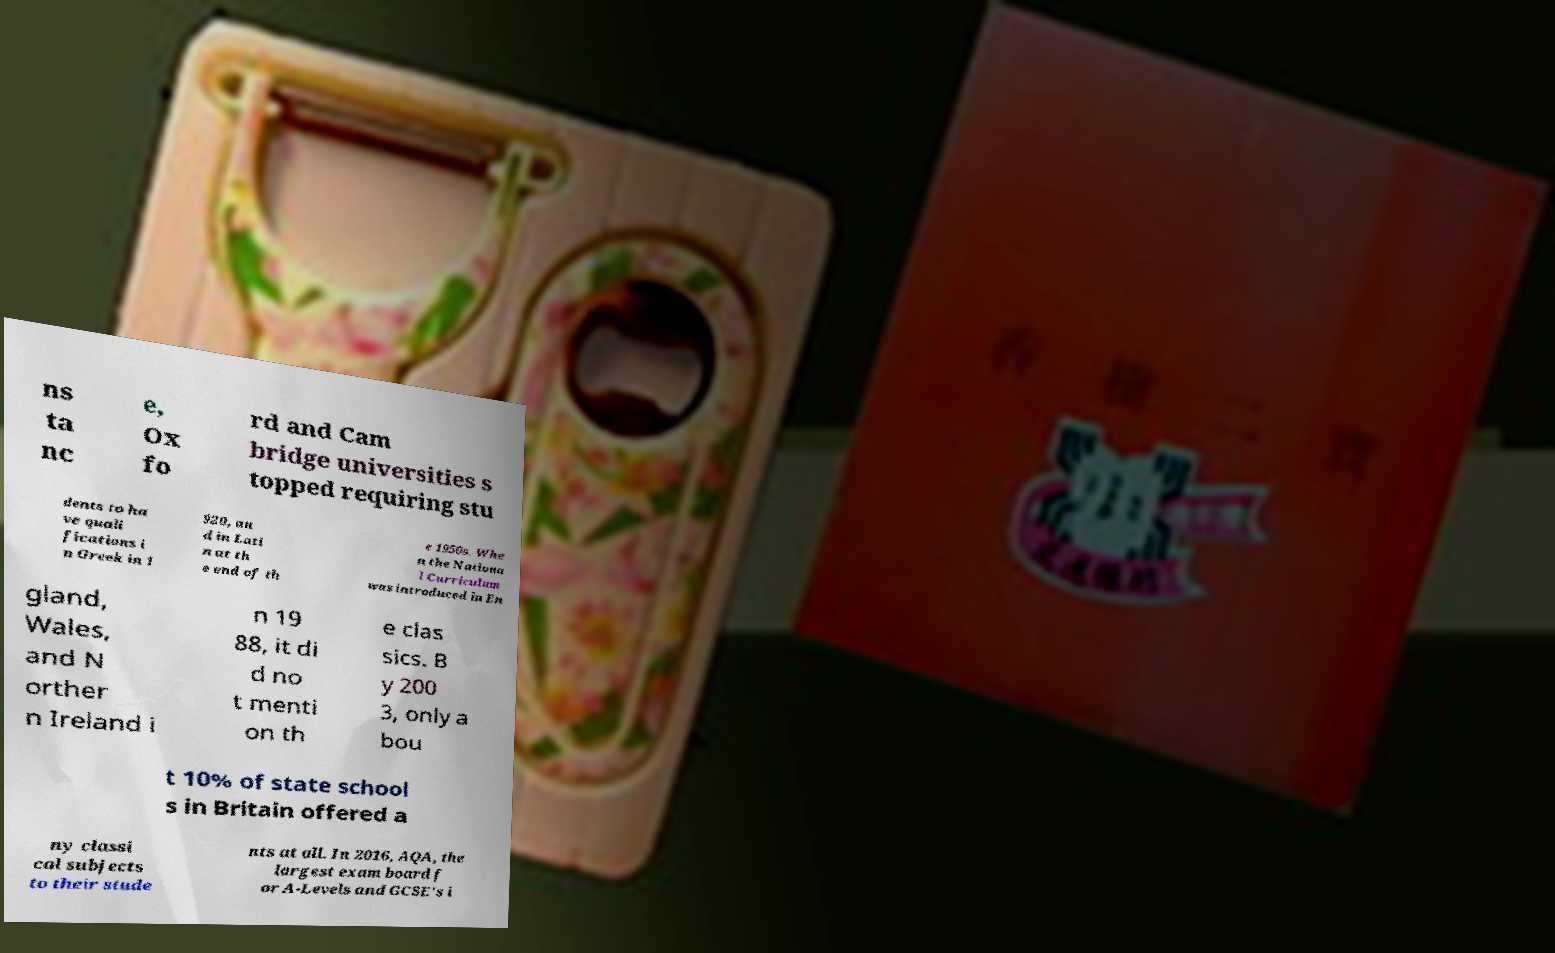Please identify and transcribe the text found in this image. ns ta nc e, Ox fo rd and Cam bridge universities s topped requiring stu dents to ha ve quali fications i n Greek in 1 920, an d in Lati n at th e end of th e 1950s. Whe n the Nationa l Curriculum was introduced in En gland, Wales, and N orther n Ireland i n 19 88, it di d no t menti on th e clas sics. B y 200 3, only a bou t 10% of state school s in Britain offered a ny classi cal subjects to their stude nts at all. In 2016, AQA, the largest exam board f or A-Levels and GCSE's i 